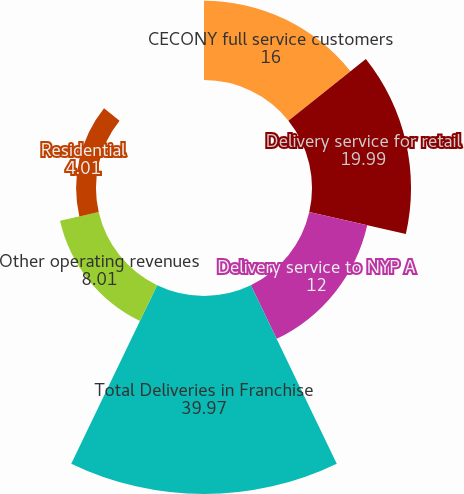<chart> <loc_0><loc_0><loc_500><loc_500><pie_chart><fcel>CECONY full service customers<fcel>Delivery service for retail<fcel>Delivery service to NYP A<fcel>Total Deliveries in Franchise<fcel>Other operating revenues<fcel>Residential<fcel>Commercial and industrial<nl><fcel>16.0%<fcel>19.99%<fcel>12.0%<fcel>39.97%<fcel>8.01%<fcel>4.01%<fcel>0.01%<nl></chart> 